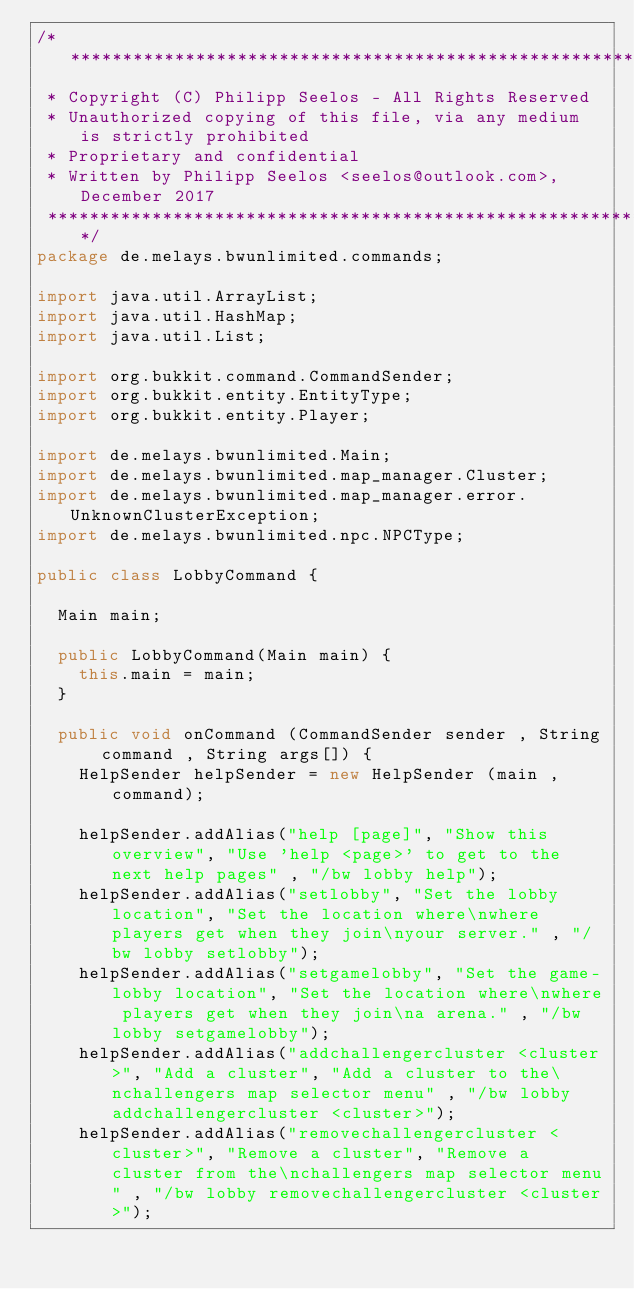<code> <loc_0><loc_0><loc_500><loc_500><_Java_>/*******************************************************************************
 * Copyright (C) Philipp Seelos - All Rights Reserved
 * Unauthorized copying of this file, via any medium is strictly prohibited
 * Proprietary and confidential
 * Written by Philipp Seelos <seelos@outlook.com>, December 2017
 ******************************************************************************/
package de.melays.bwunlimited.commands;

import java.util.ArrayList;
import java.util.HashMap;
import java.util.List;

import org.bukkit.command.CommandSender;
import org.bukkit.entity.EntityType;
import org.bukkit.entity.Player;

import de.melays.bwunlimited.Main;
import de.melays.bwunlimited.map_manager.Cluster;
import de.melays.bwunlimited.map_manager.error.UnknownClusterException;
import de.melays.bwunlimited.npc.NPCType;

public class LobbyCommand {
	
	Main main;
	
	public LobbyCommand(Main main) {
		this.main = main;
	}
	
	public void onCommand (CommandSender sender , String command , String args[]) {
		HelpSender helpSender = new HelpSender (main , command);
		
		helpSender.addAlias("help [page]", "Show this overview", "Use 'help <page>' to get to the next help pages" , "/bw lobby help");
		helpSender.addAlias("setlobby", "Set the lobby location", "Set the location where\nwhere players get when they join\nyour server." , "/bw lobby setlobby");
		helpSender.addAlias("setgamelobby", "Set the game-lobby location", "Set the location where\nwhere players get when they join\na arena." , "/bw lobby setgamelobby");
		helpSender.addAlias("addchallengercluster <cluster>", "Add a cluster", "Add a cluster to the\nchallengers map selector menu" , "/bw lobby addchallengercluster <cluster>");
		helpSender.addAlias("removechallengercluster <cluster>", "Remove a cluster", "Remove a cluster from the\nchallengers map selector menu" , "/bw lobby removechallengercluster <cluster>");</code> 